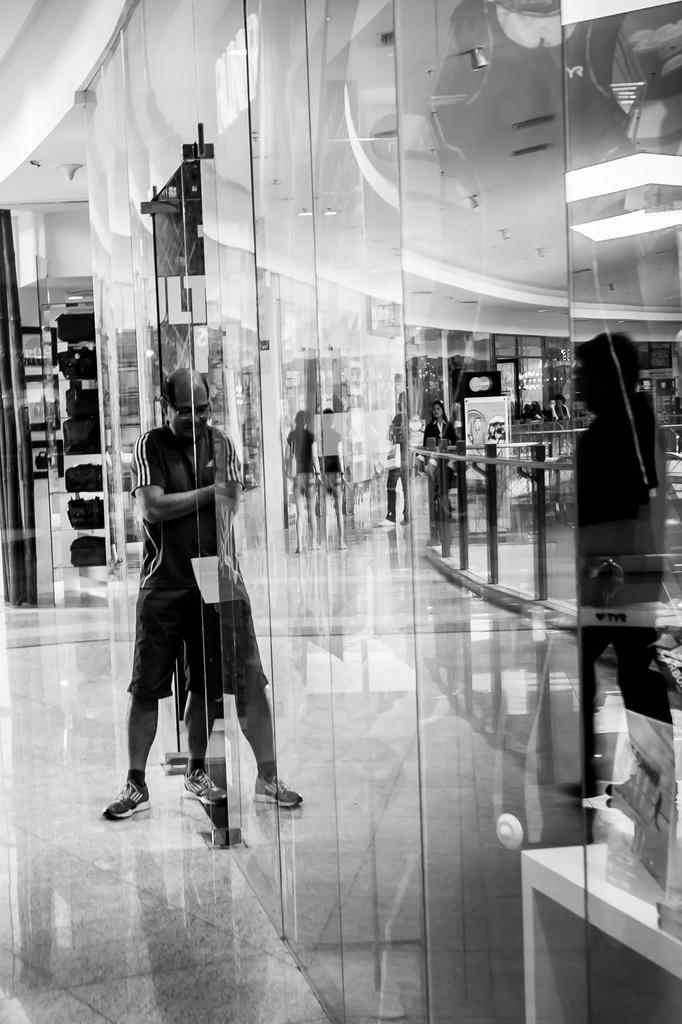What is the person in the image doing? There is a person standing on the floor in the image. What is the person wearing that is visible in the image? Glasses are present in the image. What can be seen above the person in the image? The image contains a ceiling. What is providing illumination in the image? Lights are visible in the image. What might be used for support or safety in the image? Railing is present in the image. What might the person be carrying or holding in the image? Bags are present in the image. What else is visible in the image besides the person and the mentioned objects? Other objects are visible in the image. What can be seen through the glasses in the image? Few people are visible through the glasses. What type of soup is being served in the image? There is no soup present in the image. What brand of toothpaste is visible on the person's toothbrush in the image? There is no toothbrush or toothpaste visible in the image. 